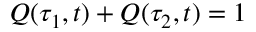<formula> <loc_0><loc_0><loc_500><loc_500>Q ( \tau _ { 1 } , t ) + Q ( \tau _ { 2 } , t ) = 1</formula> 